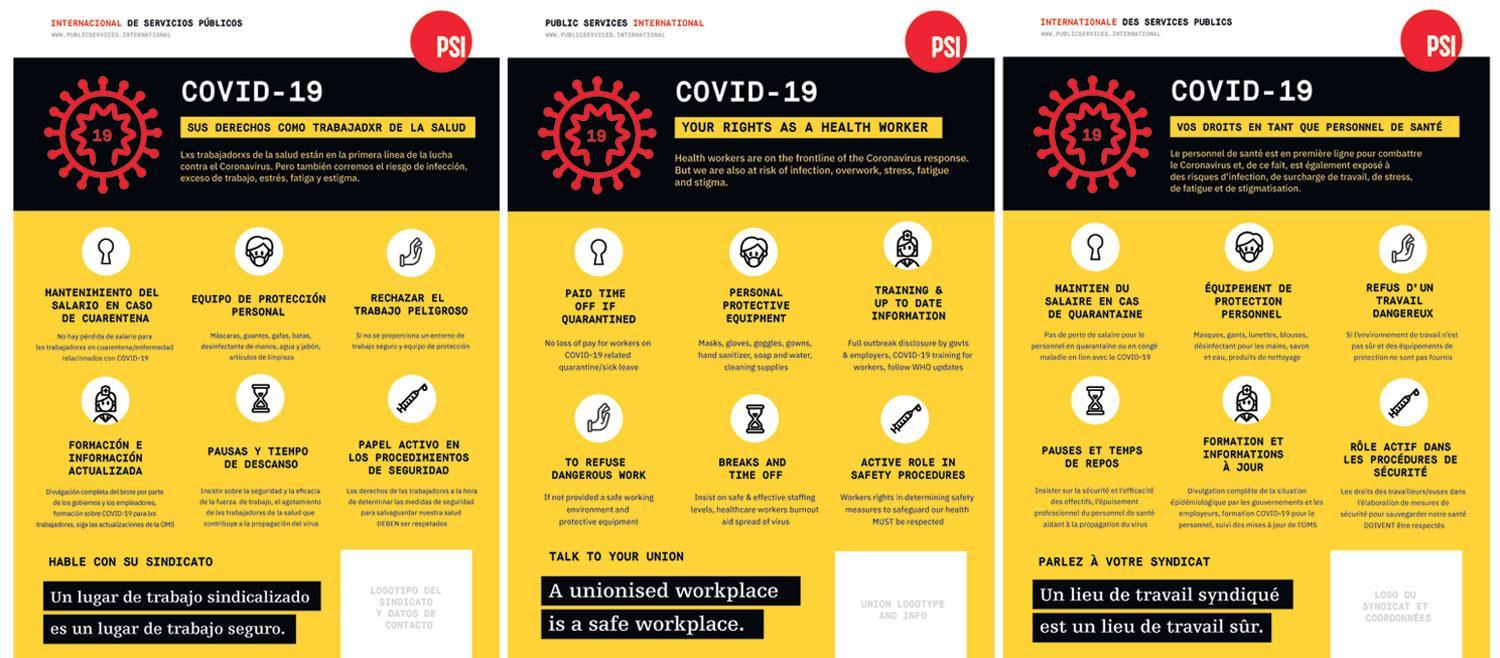Who has the right to receive training and up to date information?
Answer the question with a short phrase. health worker How many points are mentioned as the rights of a health worker? 6 Who face risk of infection, overwork, stress, fatigue and stigma? Health workers What is mentioned as the fourth point in the rights on a health worker? to refuse dangerous work 